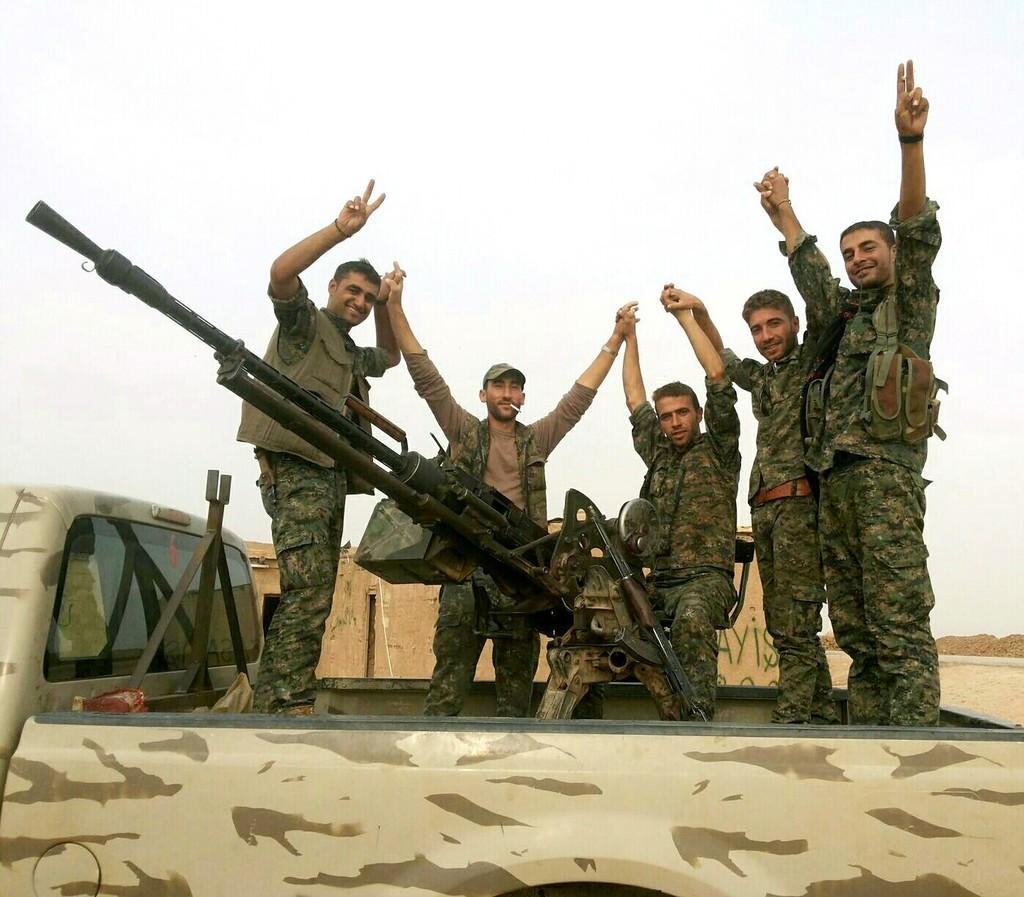What are the people in the vehicle doing? The people are standing in the vehicle. What are the people wearing? The people are wearing uniforms. What can be seen on a stand in the image? There is a rifle placed on a stand. What is visible in the background of the image? The background of the image includes the sky. What type of fowl can be seen teaching in the image? There is no fowl or teaching activity present in the image. What type of spade is being used by the people in the vehicle? There is no spade visible in the image; the people are standing in a vehicle and there is a rifle placed on a stand. 